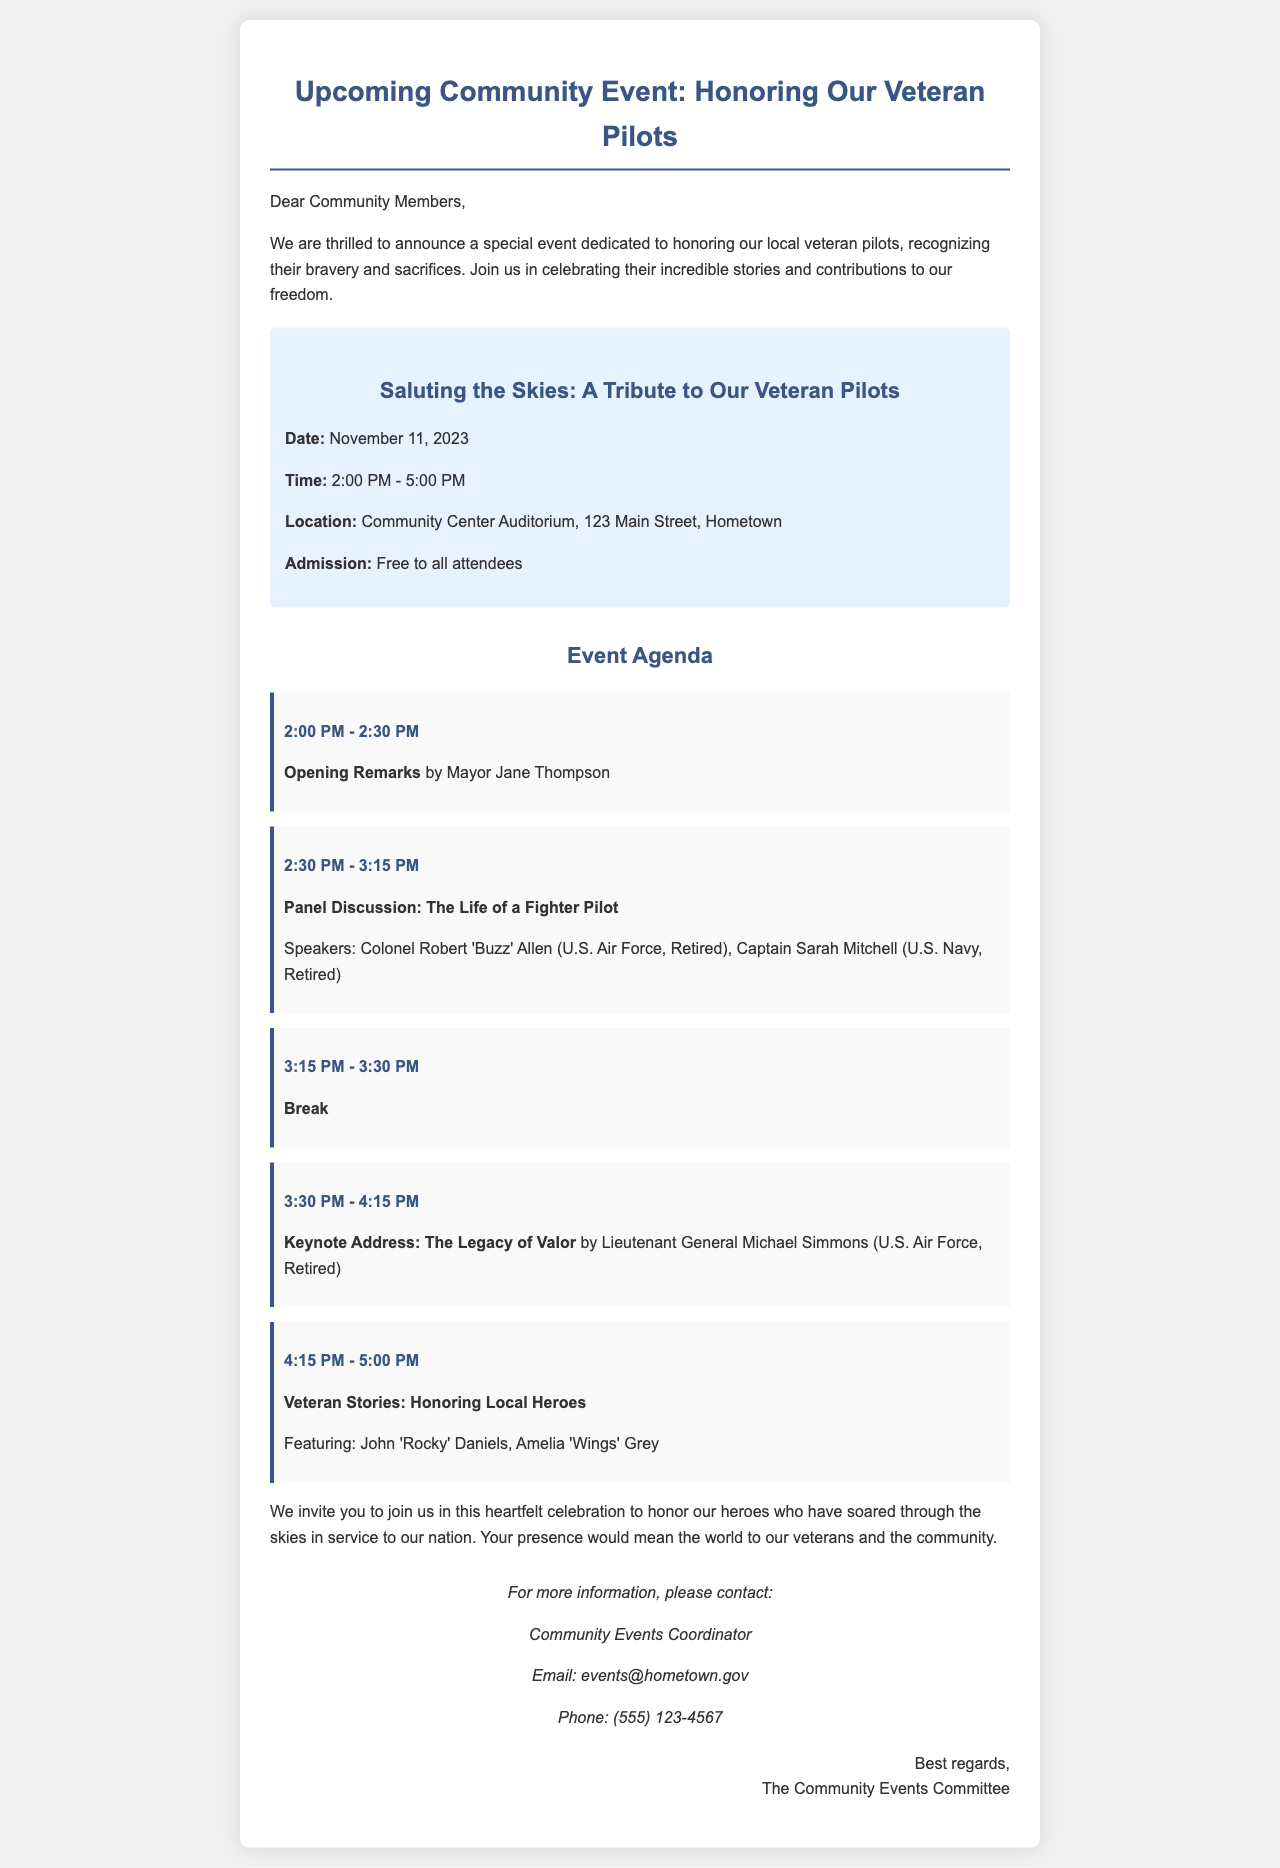What is the date of the event? The date of the event is explicitly mentioned in the document.
Answer: November 11, 2023 What time does the event start? The starting time of the event is clearly stated in the agenda section.
Answer: 2:00 PM Who gives the opening remarks? The document specifies who will deliver the opening remarks at the event.
Answer: Mayor Jane Thompson What is the location of the event? The location of the event is provided in the event details.
Answer: Community Center Auditorium, 123 Main Street, Hometown Which notable speaker is giving the keynote address? The document includes the name of the person giving the keynote address.
Answer: Lieutenant General Michael Simmons What is the theme of the panel discussion? The theme of the panel discussion is stated in the agenda.
Answer: The Life of a Fighter Pilot How long is the break during the event? The duration of the break is mentioned in the agenda.
Answer: 15 minutes Who should attendees contact for more information? The document lists the title of the person to contact for information.
Answer: Community Events Coordinator Is there an admission fee for the event? The document specifies whether there is an admission fee or not.
Answer: Free to all attendees 